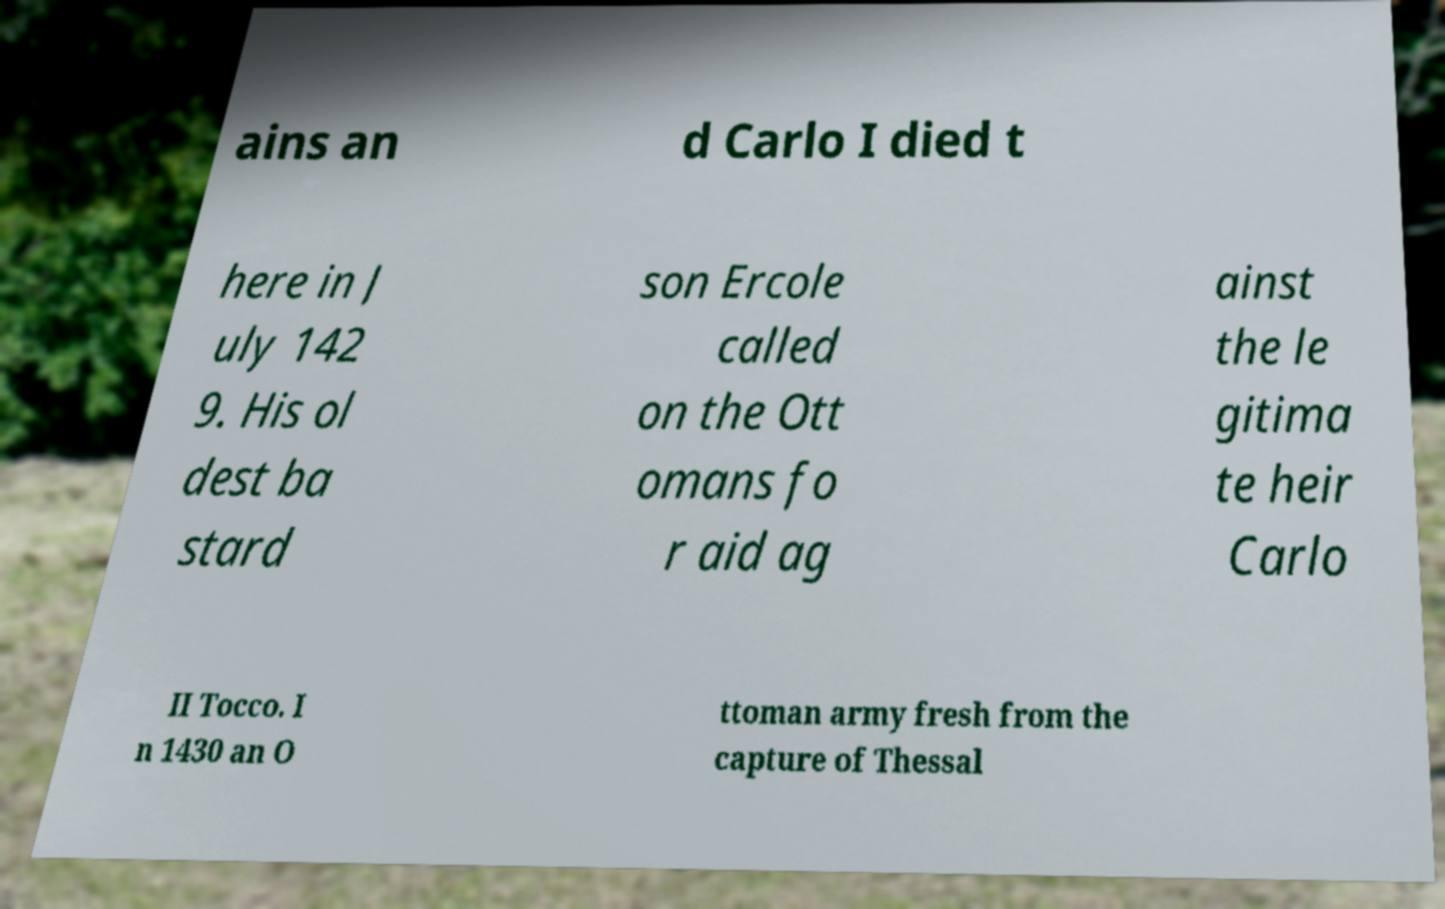For documentation purposes, I need the text within this image transcribed. Could you provide that? ains an d Carlo I died t here in J uly 142 9. His ol dest ba stard son Ercole called on the Ott omans fo r aid ag ainst the le gitima te heir Carlo II Tocco. I n 1430 an O ttoman army fresh from the capture of Thessal 